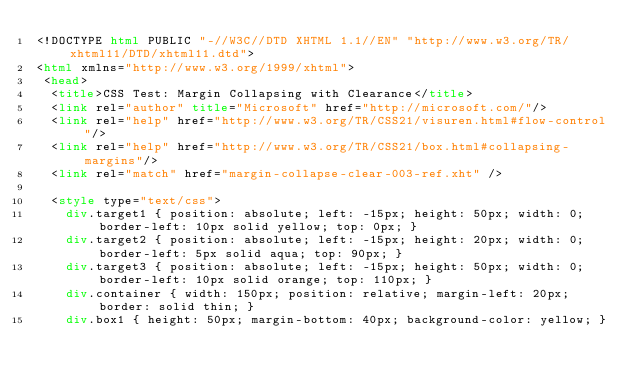<code> <loc_0><loc_0><loc_500><loc_500><_HTML_><!DOCTYPE html PUBLIC "-//W3C//DTD XHTML 1.1//EN" "http://www.w3.org/TR/xhtml11/DTD/xhtml11.dtd">
<html xmlns="http://www.w3.org/1999/xhtml">
 <head>
  <title>CSS Test: Margin Collapsing with Clearance</title>
  <link rel="author" title="Microsoft" href="http://microsoft.com/"/>
  <link rel="help" href="http://www.w3.org/TR/CSS21/visuren.html#flow-control"/>
  <link rel="help" href="http://www.w3.org/TR/CSS21/box.html#collapsing-margins"/>
  <link rel="match" href="margin-collapse-clear-003-ref.xht" />

  <style type="text/css">
    div.target1 { position: absolute; left: -15px; height: 50px; width: 0; border-left: 10px solid yellow; top: 0px; }
    div.target2 { position: absolute; left: -15px; height: 20px; width: 0; border-left: 5px solid aqua; top: 90px; }
    div.target3 { position: absolute; left: -15px; height: 50px; width: 0; border-left: 10px solid orange; top: 110px; }
    div.container { width: 150px; position: relative; margin-left: 20px; border: solid thin; }
    div.box1 { height: 50px; margin-bottom: 40px; background-color: yellow; }</code> 